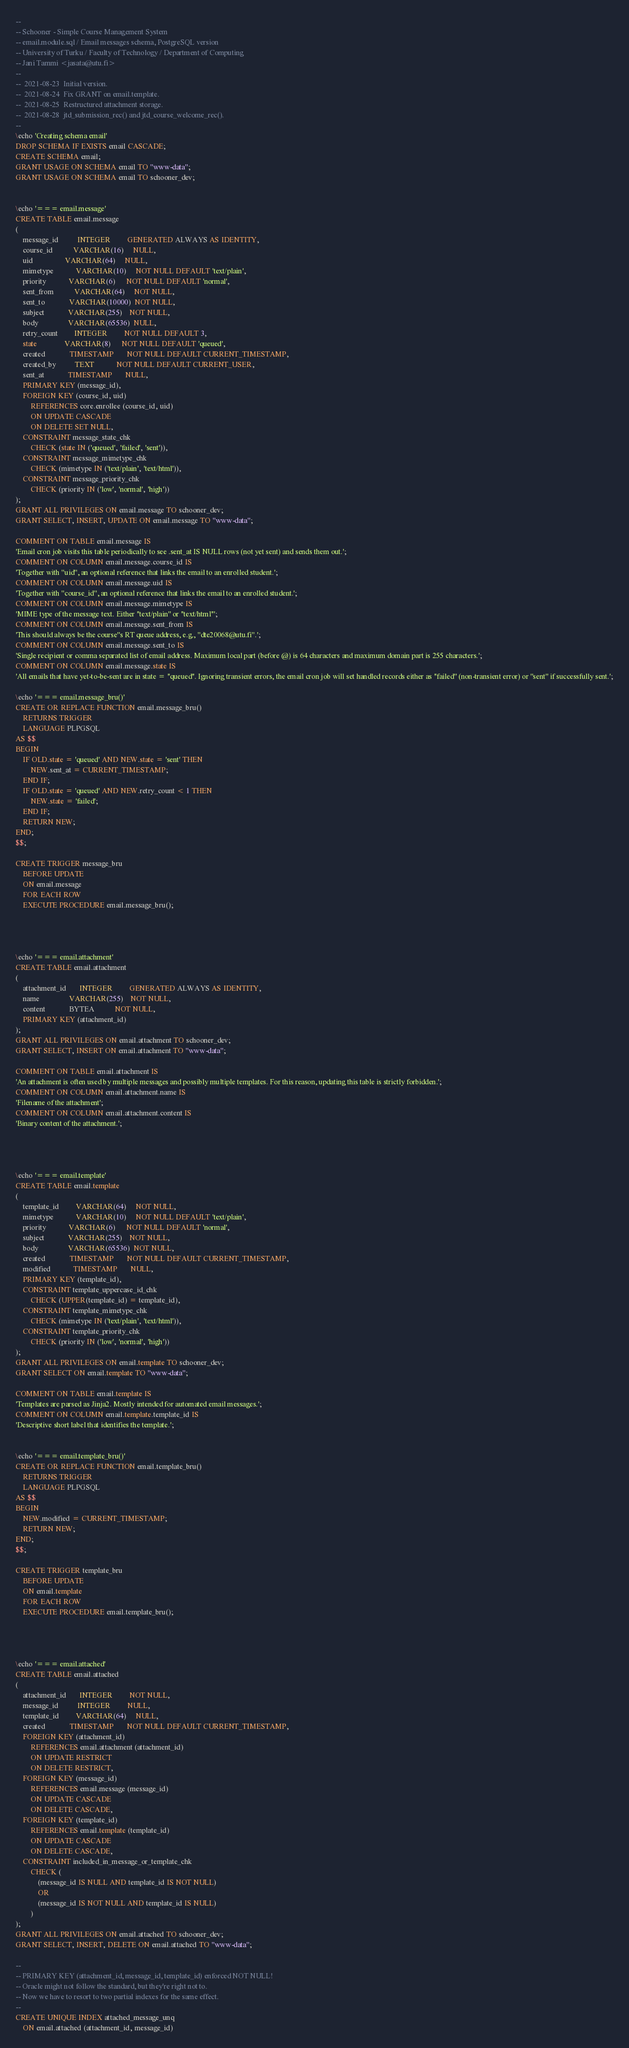<code> <loc_0><loc_0><loc_500><loc_500><_SQL_>--
-- Schooner - Simple Course Management System
-- email.module.sql / Email messages schema, PostgreSQL version
-- University of Turku / Faculty of Technology / Department of Computing
-- Jani Tammi <jasata@utu.fi>
--
--  2021-08-23  Initial version.
--  2021-08-24  Fix GRANT on email.template.
--  2021-08-25  Restructured attachment storage.
--  2021-08-28  jtd_submission_rec() and jtd_course_welcome_rec().
--
\echo 'Creating schema email'
DROP SCHEMA IF EXISTS email CASCADE;
CREATE SCHEMA email;
GRANT USAGE ON SCHEMA email TO "www-data";
GRANT USAGE ON SCHEMA email TO schooner_dev;


\echo '=== email.message'
CREATE TABLE email.message
(
    message_id          INTEGER         GENERATED ALWAYS AS IDENTITY,
    course_id           VARCHAR(16)     NULL,
    uid                 VARCHAR(64)     NULL,
    mimetype            VARCHAR(10)     NOT NULL DEFAULT 'text/plain',
    priority            VARCHAR(6)      NOT NULL DEFAULT 'normal',
    sent_from           VARCHAR(64)     NOT NULL,
    sent_to             VARCHAR(10000)  NOT NULL,
    subject             VARCHAR(255)    NOT NULL,
    body                VARCHAR(65536)  NULL,
    retry_count         INTEGER         NOT NULL DEFAULT 3,
    state               VARCHAR(8)      NOT NULL DEFAULT 'queued',
    created             TIMESTAMP       NOT NULL DEFAULT CURRENT_TIMESTAMP,
    created_by          TEXT            NOT NULL DEFAULT CURRENT_USER,
    sent_at             TIMESTAMP       NULL,
    PRIMARY KEY (message_id),
    FOREIGN KEY (course_id, uid)
        REFERENCES core.enrollee (course_id, uid)
        ON UPDATE CASCADE
        ON DELETE SET NULL,
    CONSTRAINT message_state_chk
        CHECK (state IN ('queued', 'failed', 'sent')),
    CONSTRAINT message_mimetype_chk
        CHECK (mimetype IN ('text/plain', 'text/html')),
    CONSTRAINT message_priority_chk
        CHECK (priority IN ('low', 'normal', 'high'))
);
GRANT ALL PRIVILEGES ON email.message TO schooner_dev;
GRANT SELECT, INSERT, UPDATE ON email.message TO "www-data";

COMMENT ON TABLE email.message IS
'Email cron job visits this table periodically to see .sent_at IS NULL rows (not yet sent) and sends them out.';
COMMENT ON COLUMN email.message.course_id IS
'Together with "uid", an optional reference that links the email to an enrolled student.';
COMMENT ON COLUMN email.message.uid IS
'Together with "course_id", an optional reference that links the email to an enrolled student.';
COMMENT ON COLUMN email.message.mimetype IS
'MIME type of the message text. Either ''text/plain'' or ''text/html''';
COMMENT ON COLUMN email.message.sent_from IS
'This should always be the course''s RT queue address, e.g., "dte20068@utu.fi".';
COMMENT ON COLUMN email.message.sent_to IS
'Single recipient or comma separated list of email address. Maximum local part (before @) is 64 characters and maximum domain part is 255 characters.';
COMMENT ON COLUMN email.message.state IS
'All emails that have yet-to-be-sent are in state = ''queued''. Ignoring transient errors, the email cron job will set handled records either as ''failed'' (non-transient error) or ''sent'' if successfully sent.';

\echo '=== email.message_bru()'
CREATE OR REPLACE FUNCTION email.message_bru()
    RETURNS TRIGGER
    LANGUAGE PLPGSQL
AS $$
BEGIN
    IF OLD.state = 'queued' AND NEW.state = 'sent' THEN
        NEW.sent_at = CURRENT_TIMESTAMP;
    END IF;
    IF OLD.state = 'queued' AND NEW.retry_count < 1 THEN
        NEW.state = 'failed';
    END IF;
    RETURN NEW;
END;
$$;

CREATE TRIGGER message_bru
    BEFORE UPDATE
    ON email.message
    FOR EACH ROW
    EXECUTE PROCEDURE email.message_bru();




\echo '=== email.attachment'
CREATE TABLE email.attachment
(
    attachment_id       INTEGER         GENERATED ALWAYS AS IDENTITY,
    name                VARCHAR(255)    NOT NULL,
    content             BYTEA           NOT NULL,
    PRIMARY KEY (attachment_id)
);
GRANT ALL PRIVILEGES ON email.attachment TO schooner_dev;
GRANT SELECT, INSERT ON email.attachment TO "www-data";

COMMENT ON TABLE email.attachment IS
'An attachment is often used by multiple messages and possibly multiple templates. For this reason, updating this table is strictly forbidden.';
COMMENT ON COLUMN email.attachment.name IS
'Filename of the attachment';
COMMENT ON COLUMN email.attachment.content IS
'Binary content of the attachment.';




\echo '=== email.template'
CREATE TABLE email.template
(
    template_id         VARCHAR(64)     NOT NULL,
    mimetype            VARCHAR(10)     NOT NULL DEFAULT 'text/plain',
    priority            VARCHAR(6)      NOT NULL DEFAULT 'normal',
    subject             VARCHAR(255)    NOT NULL,
    body                VARCHAR(65536)  NOT NULL,
    created             TIMESTAMP       NOT NULL DEFAULT CURRENT_TIMESTAMP,
    modified            TIMESTAMP       NULL,
    PRIMARY KEY (template_id),
    CONSTRAINT template_uppercase_id_chk
        CHECK (UPPER(template_id) = template_id),
    CONSTRAINT template_mimetype_chk
        CHECK (mimetype IN ('text/plain', 'text/html')),
    CONSTRAINT template_priority_chk
        CHECK (priority IN ('low', 'normal', 'high'))
);
GRANT ALL PRIVILEGES ON email.template TO schooner_dev;
GRANT SELECT ON email.template TO "www-data";

COMMENT ON TABLE email.template IS
'Templates are parsed as Jinja2. Mostly intended for automated email messages.';
COMMENT ON COLUMN email.template.template_id IS
'Descriptive short label that identifies the template.';


\echo '=== email.template_bru()'
CREATE OR REPLACE FUNCTION email.template_bru()
    RETURNS TRIGGER
    LANGUAGE PLPGSQL
AS $$
BEGIN
    NEW.modified = CURRENT_TIMESTAMP;
    RETURN NEW;
END;
$$;

CREATE TRIGGER template_bru
    BEFORE UPDATE
    ON email.template
    FOR EACH ROW
    EXECUTE PROCEDURE email.template_bru();




\echo '=== email.attached'
CREATE TABLE email.attached
(
    attachment_id       INTEGER         NOT NULL,
    message_id          INTEGER         NULL,
    template_id         VARCHAR(64)     NULL,
    created             TIMESTAMP       NOT NULL DEFAULT CURRENT_TIMESTAMP,
    FOREIGN KEY (attachment_id)
        REFERENCES email.attachment (attachment_id)
        ON UPDATE RESTRICT
        ON DELETE RESTRICT,
    FOREIGN KEY (message_id)
        REFERENCES email.message (message_id)
        ON UPDATE CASCADE
        ON DELETE CASCADE,
    FOREIGN KEY (template_id)
        REFERENCES email.template (template_id)
        ON UPDATE CASCADE
        ON DELETE CASCADE,
    CONSTRAINT included_in_message_or_template_chk
        CHECK (
            (message_id IS NULL AND template_id IS NOT NULL)
            OR
            (message_id IS NOT NULL AND template_id IS NULL)
        )
);
GRANT ALL PRIVILEGES ON email.attached TO schooner_dev;
GRANT SELECT, INSERT, DELETE ON email.attached TO "www-data";

--
-- PRIMARY KEY (attachment_id, message_id, template_id) enforced NOT NULL!
-- Oracle might not follow the standard, but they're right not to.
-- Now we have to resort to two partial indexes for the same effect.
--
CREATE UNIQUE INDEX attached_message_unq
    ON email.attached (attachment_id, message_id)</code> 